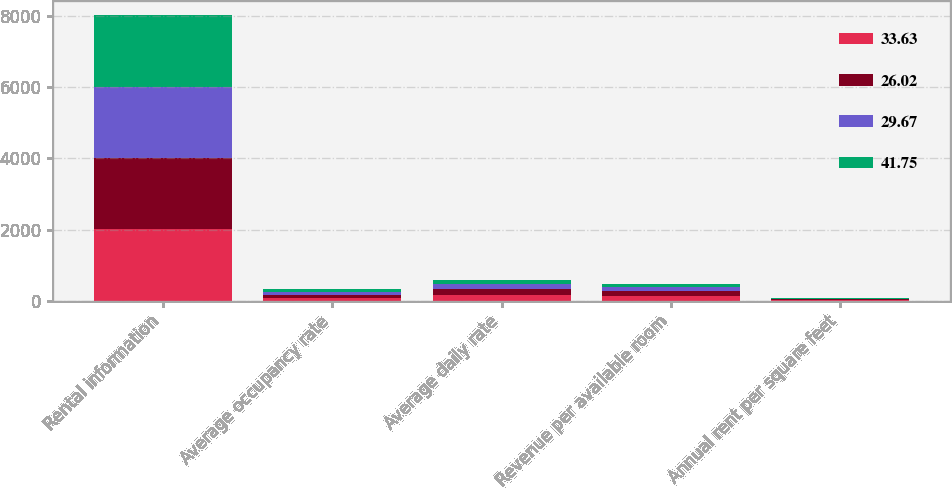<chart> <loc_0><loc_0><loc_500><loc_500><stacked_bar_chart><ecel><fcel>Rental information<fcel>Average occupancy rate<fcel>Average daily rate<fcel>Revenue per available room<fcel>Annual rent per square feet<nl><fcel>33.63<fcel>2008<fcel>84.1<fcel>171.32<fcel>144.01<fcel>18.78<nl><fcel>26.02<fcel>2007<fcel>84.4<fcel>154.78<fcel>130.7<fcel>22.23<nl><fcel>29.67<fcel>2006<fcel>82.1<fcel>133.33<fcel>109.53<fcel>16.42<nl><fcel>41.75<fcel>2005<fcel>83.7<fcel>115.74<fcel>96.85<fcel>10.7<nl></chart> 